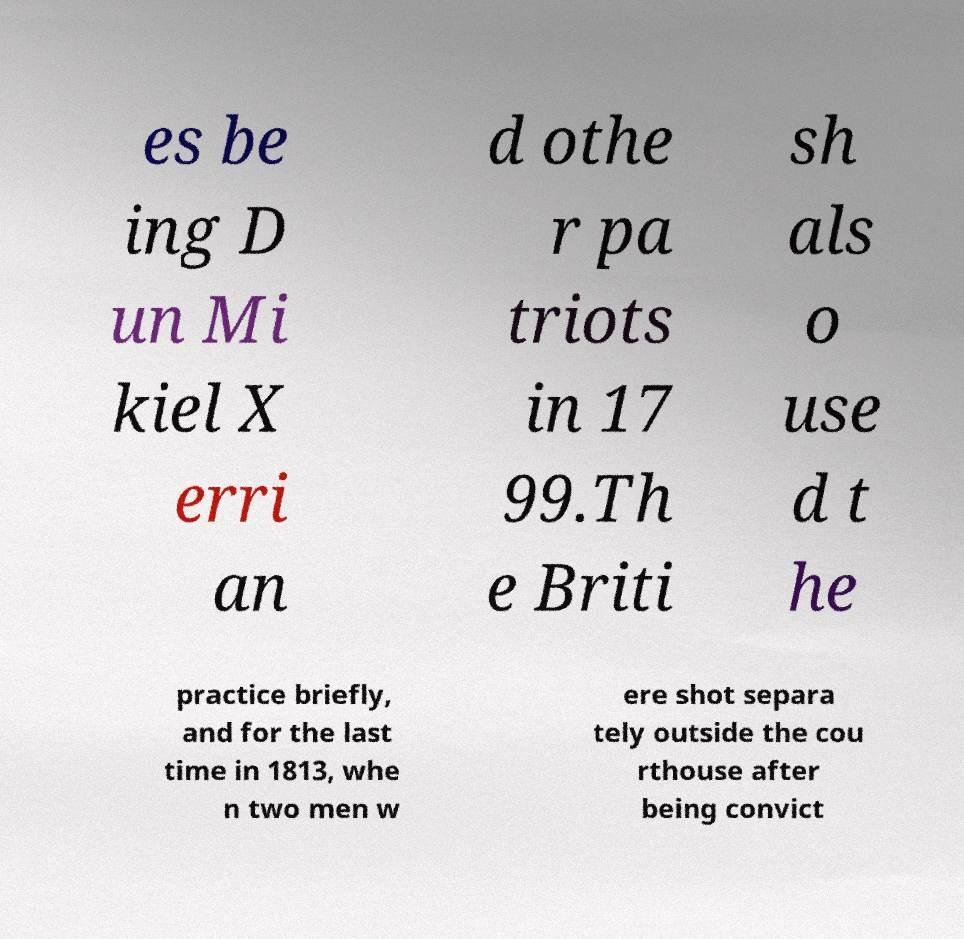There's text embedded in this image that I need extracted. Can you transcribe it verbatim? es be ing D un Mi kiel X erri an d othe r pa triots in 17 99.Th e Briti sh als o use d t he practice briefly, and for the last time in 1813, whe n two men w ere shot separa tely outside the cou rthouse after being convict 